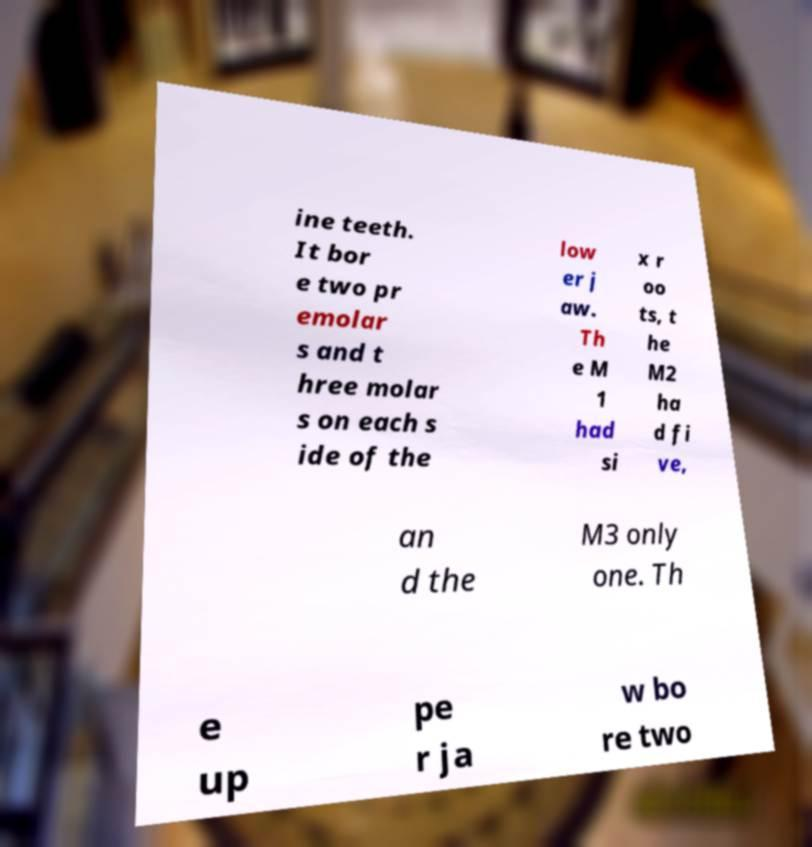Please identify and transcribe the text found in this image. ine teeth. It bor e two pr emolar s and t hree molar s on each s ide of the low er j aw. Th e M 1 had si x r oo ts, t he M2 ha d fi ve, an d the M3 only one. Th e up pe r ja w bo re two 